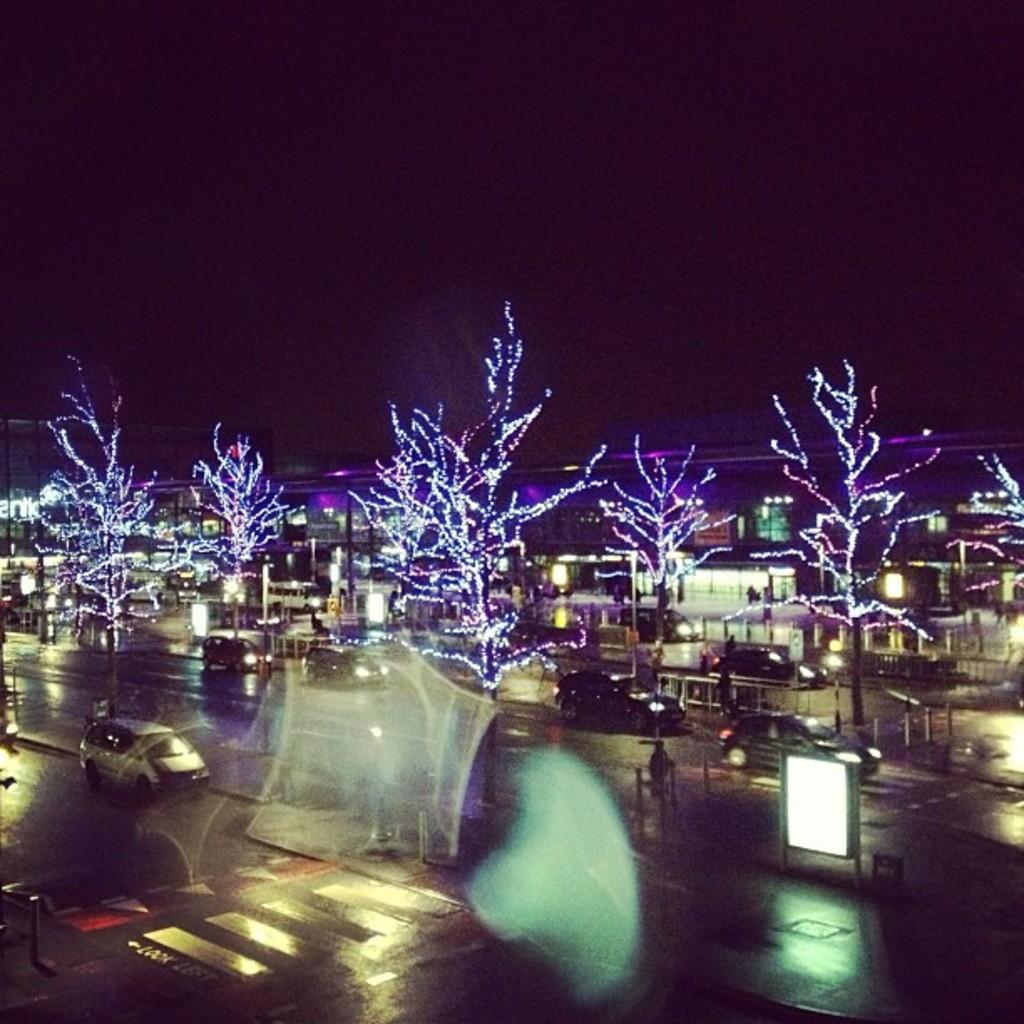How would you summarize this image in a sentence or two? In this image we can see some vehicles on the road, there are some people, trees, buildings, lights, poles and boards, also we can see the background is dark. 